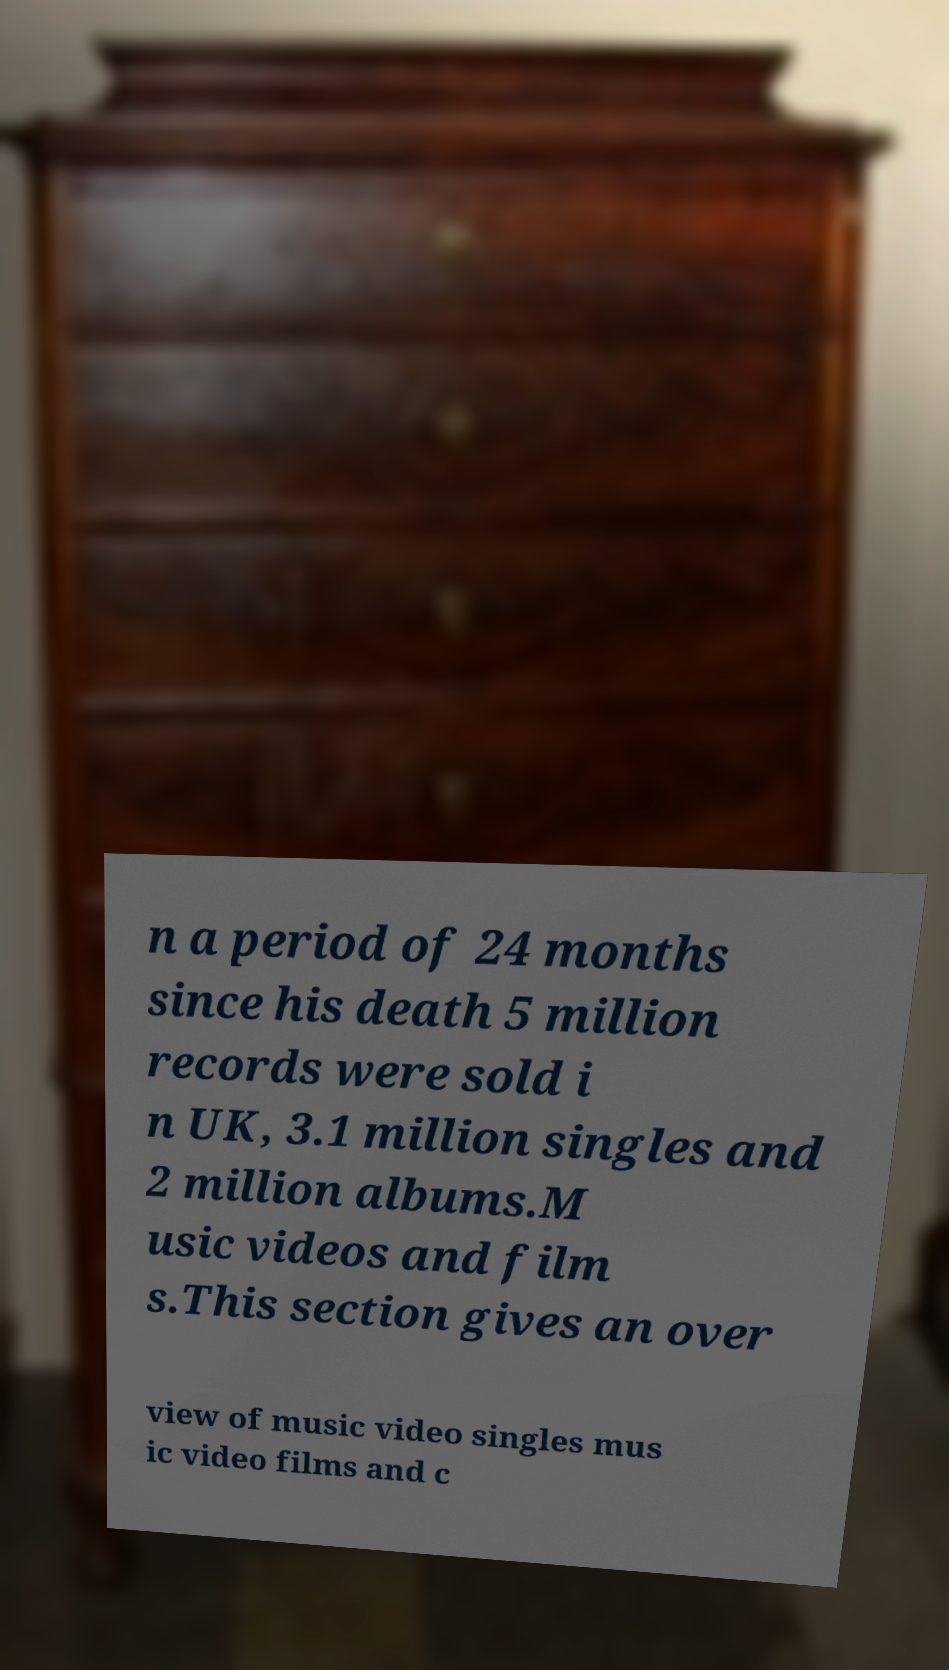What messages or text are displayed in this image? I need them in a readable, typed format. n a period of 24 months since his death 5 million records were sold i n UK, 3.1 million singles and 2 million albums.M usic videos and film s.This section gives an over view of music video singles mus ic video films and c 